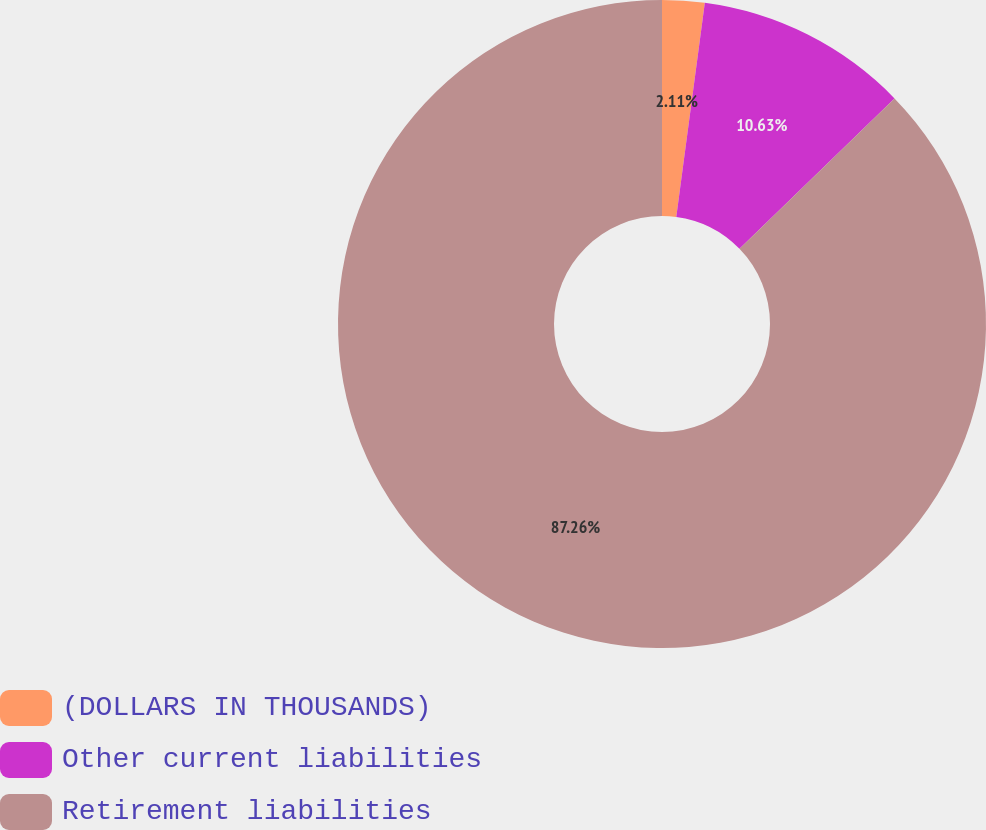Convert chart to OTSL. <chart><loc_0><loc_0><loc_500><loc_500><pie_chart><fcel>(DOLLARS IN THOUSANDS)<fcel>Other current liabilities<fcel>Retirement liabilities<nl><fcel>2.11%<fcel>10.63%<fcel>87.26%<nl></chart> 